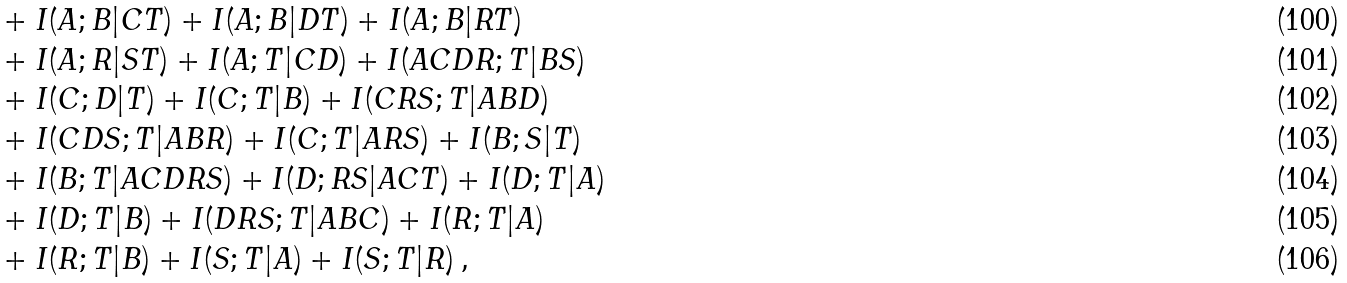<formula> <loc_0><loc_0><loc_500><loc_500>& \ \ + I ( A ; B | C T ) + I ( A ; B | D T ) + I ( A ; B | R T ) \\ & \ \ + I ( A ; R | S T ) + I ( A ; T | C D ) + I ( A C D R ; T | B S ) \\ & \ \ + I ( C ; D | T ) + I ( C ; T | B ) + I ( C R S ; T | A B D ) \\ & \ \ + I ( C D S ; T | A B R ) + I ( C ; T | A R S ) + I ( B ; S | T ) \\ & \ \ + I ( B ; T | A C D R S ) + I ( D ; R S | A C T ) + I ( D ; T | A ) \\ & \ \ + I ( D ; T | B ) + I ( D R S ; T | A B C ) + I ( R ; T | A ) \\ & \ \ + I ( R ; T | B ) + I ( S ; T | A ) + I ( S ; T | R ) \, ,</formula> 